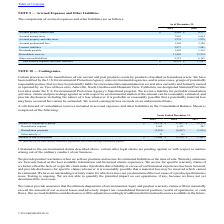From Cts Corporation's financial document, Which years does the table provide information for the components of accrued expenses and other liabilities? The document shows two values: 2019 and 2018. From the document: "2019 2018 2019 2018..." Also, What were the Remediation reserves in 2019? According to the financial document, 11,444 (in thousands). The relevant text states: "Remediation reserves 11,444 11,274..." Also, What was the Total accrued expenses and other liabilities in 2018? According to the financial document, 37,347 (in thousands). The relevant text states: "accrued expenses and other liabilities $ 36,378 $ 37,347..." Additionally, Which years did Dividends payable exceed $1,000 thousand? The document shows two values: 2019 and 2018. From the document: "2019 2018 2019 2018..." Also, can you calculate: What was the change in contract liabilities between 2018 and 2019? Based on the calculation: 2,877-1,981, the result is 896 (in thousands). This is based on the information: "Contract liabilities 2,877 1,981 Contract liabilities 2,877 1,981..." The key data points involved are: 1,981, 2,877. Also, can you calculate: What was the percentage change in the Other accrued liabilities between 2018 and 2019? To answer this question, I need to perform calculations using the financial data. The calculation is: (5,218-6,165)/6,165, which equals -15.36 (percentage). This is based on the information: "Other accrued liabilities 5,218 6,165 Other accrued liabilities 5,218 6,165..." The key data points involved are: 5,218, 6,165. 